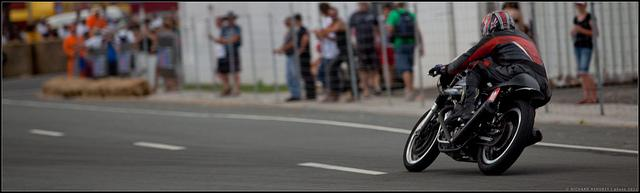Why is the rider's head covered? safety 